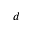<formula> <loc_0><loc_0><loc_500><loc_500>d</formula> 